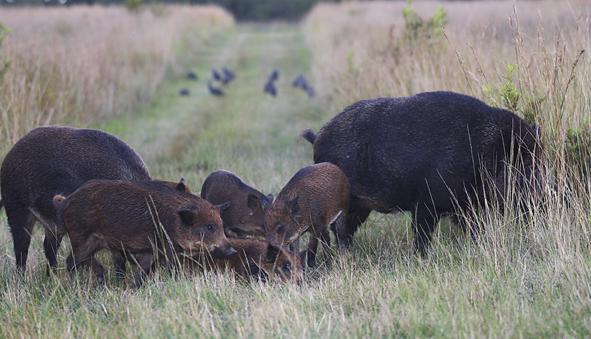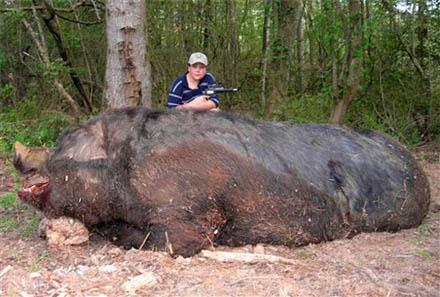The first image is the image on the left, the second image is the image on the right. Assess this claim about the two images: "An image contains multiple dark adult boars, and at least seven striped juvenile pigs.". Correct or not? Answer yes or no. No. The first image is the image on the left, the second image is the image on the right. Analyze the images presented: Is the assertion "All boars in the right image are facing right." valid? Answer yes or no. No. 